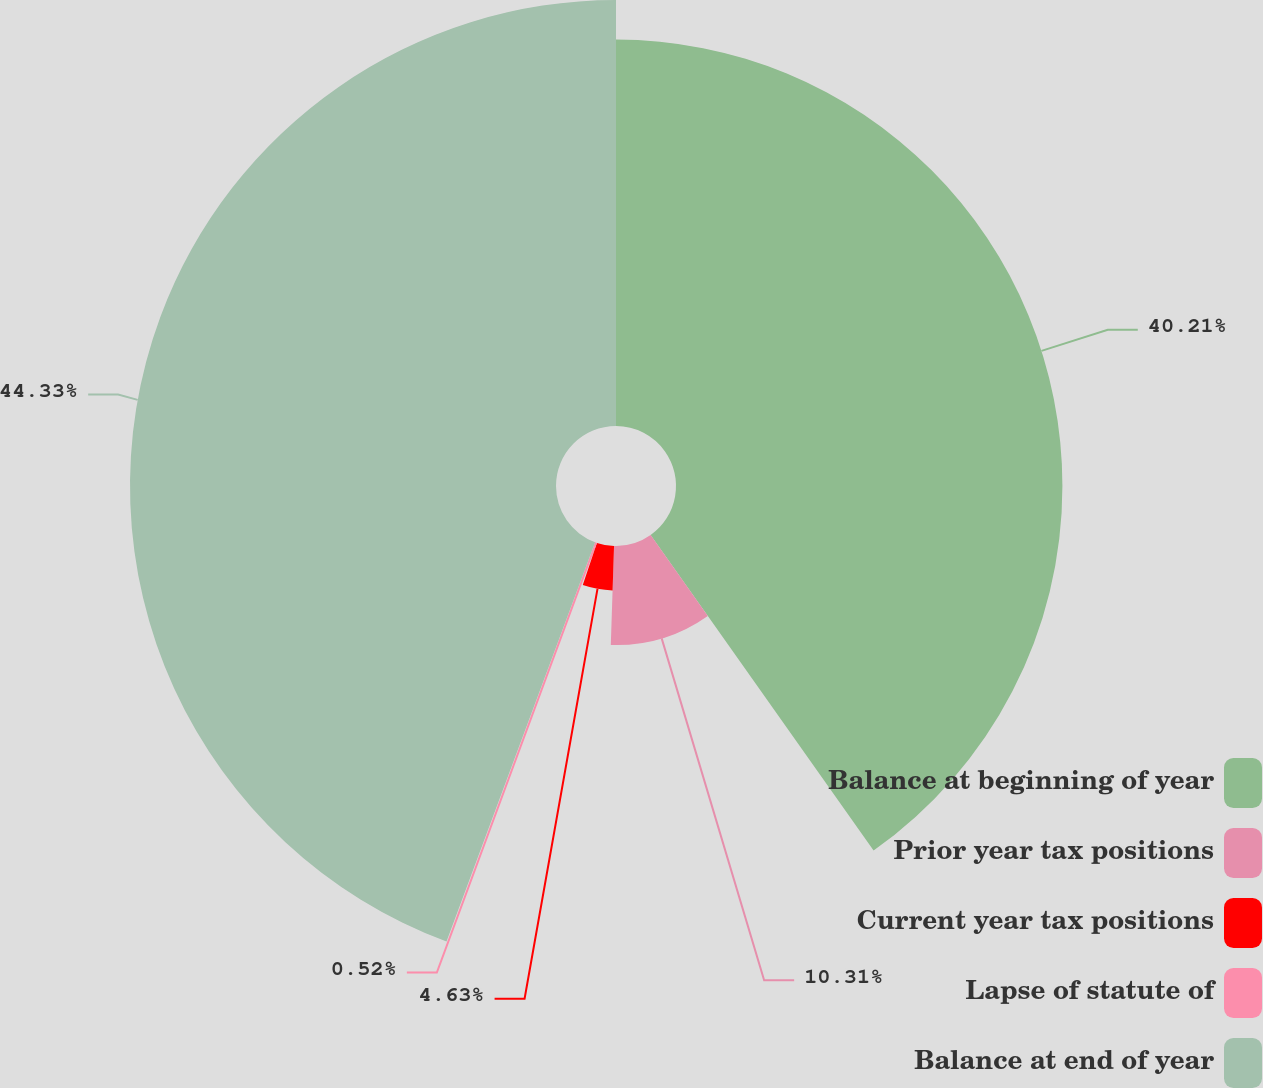Convert chart to OTSL. <chart><loc_0><loc_0><loc_500><loc_500><pie_chart><fcel>Balance at beginning of year<fcel>Prior year tax positions<fcel>Current year tax positions<fcel>Lapse of statute of<fcel>Balance at end of year<nl><fcel>40.21%<fcel>10.31%<fcel>4.63%<fcel>0.52%<fcel>44.33%<nl></chart> 